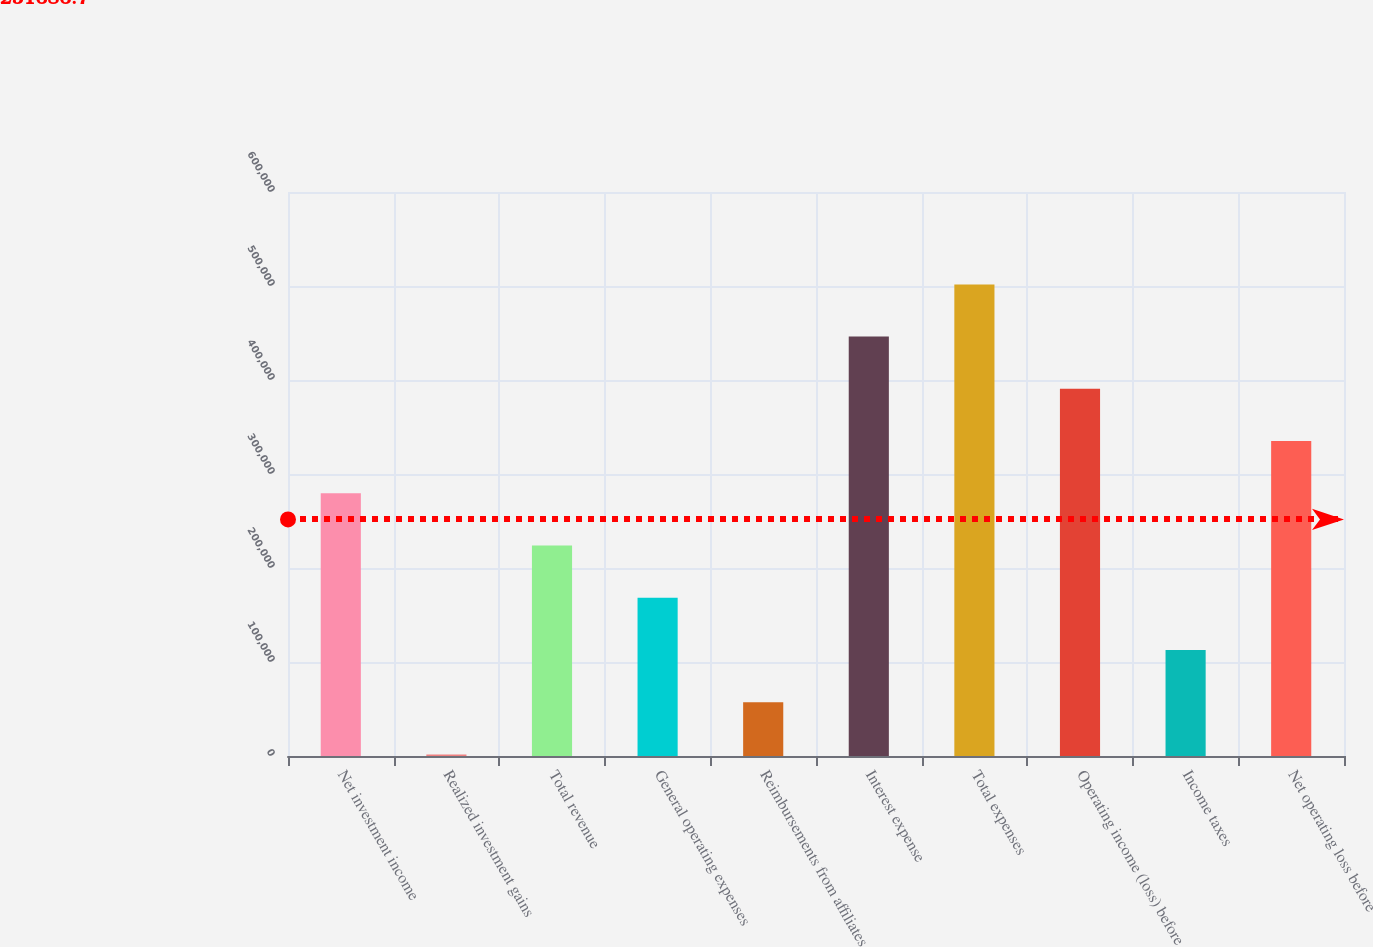Convert chart to OTSL. <chart><loc_0><loc_0><loc_500><loc_500><bar_chart><fcel>Net investment income<fcel>Realized investment gains<fcel>Total revenue<fcel>General operating expenses<fcel>Reimbursements from affiliates<fcel>Interest expense<fcel>Total expenses<fcel>Operating income (loss) before<fcel>Income taxes<fcel>Net operating loss before<nl><fcel>279469<fcel>1646<fcel>223904<fcel>168340<fcel>57210.6<fcel>446163<fcel>501727<fcel>390598<fcel>112775<fcel>335034<nl></chart> 